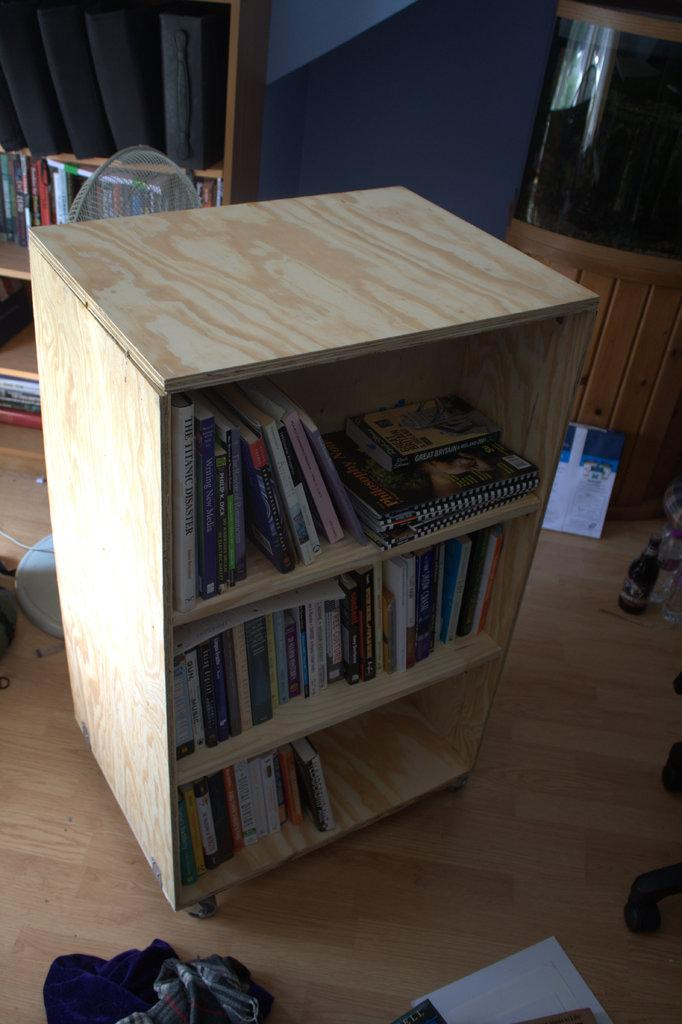What can be seen in the racks in the image? There are books in the racks in the image. What device is present in the image for cooling or circulating air? There is a fan in the image. What type of container is visible in the image? There is a bottle in the image. How many bananas are hanging from the fan in the image? There are no bananas present in the image; the fan is used for cooling or circulating air. 